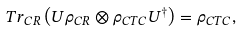Convert formula to latex. <formula><loc_0><loc_0><loc_500><loc_500>T r _ { C R } \left ( U \rho _ { C R } \otimes \rho _ { C T C } U ^ { \dagger } \right ) = \rho _ { C T C } ,</formula> 